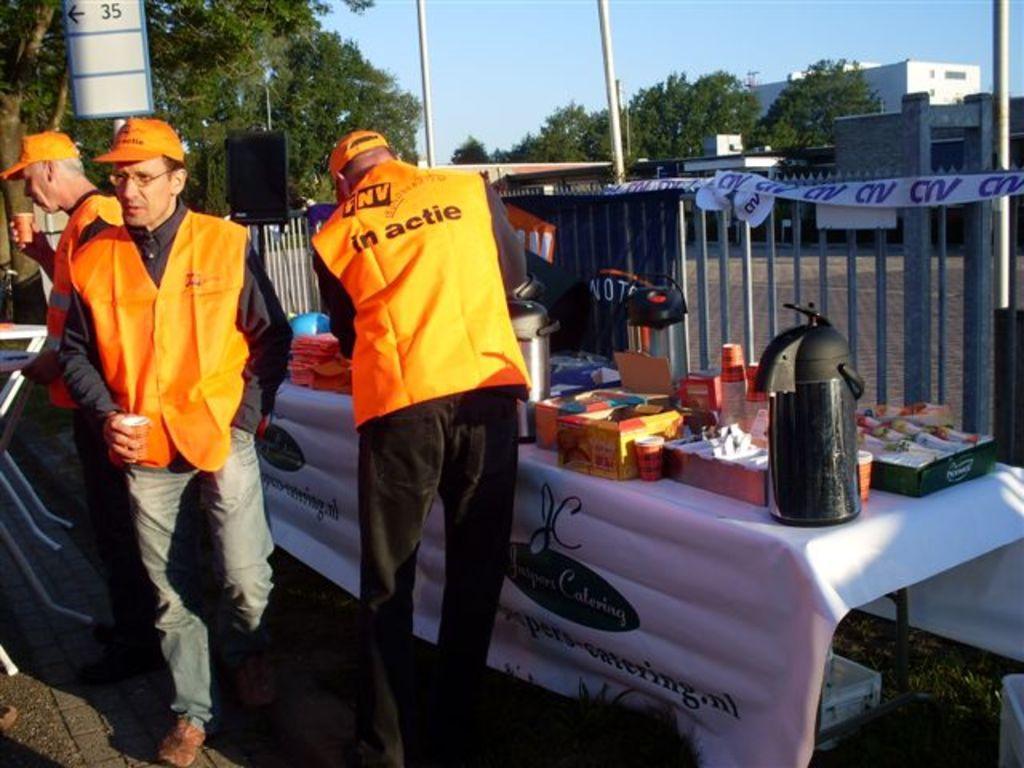How would you summarize this image in a sentence or two? In this image I see 3 men, who are wearing the same dress and I see a table and there are lot of things on it. In the background I see the trees, poles, buildings and the sky. 